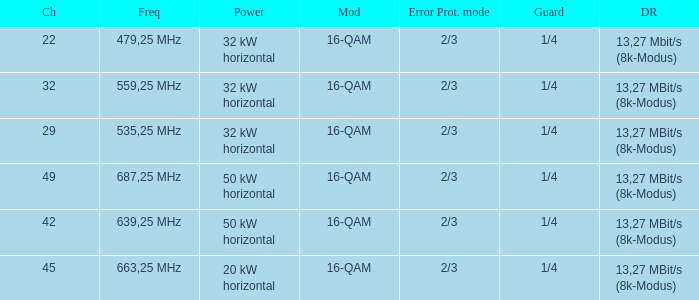On channel 32, when the power is 32 kW horizontal, what is the frequency? 559,25 MHz. 